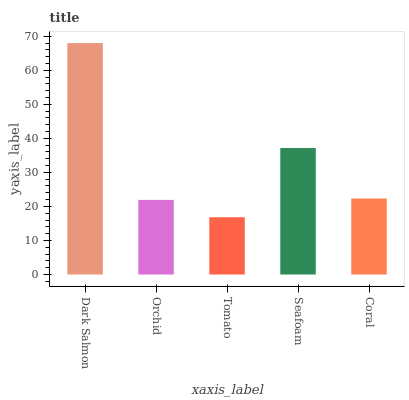Is Orchid the minimum?
Answer yes or no. No. Is Orchid the maximum?
Answer yes or no. No. Is Dark Salmon greater than Orchid?
Answer yes or no. Yes. Is Orchid less than Dark Salmon?
Answer yes or no. Yes. Is Orchid greater than Dark Salmon?
Answer yes or no. No. Is Dark Salmon less than Orchid?
Answer yes or no. No. Is Coral the high median?
Answer yes or no. Yes. Is Coral the low median?
Answer yes or no. Yes. Is Orchid the high median?
Answer yes or no. No. Is Seafoam the low median?
Answer yes or no. No. 